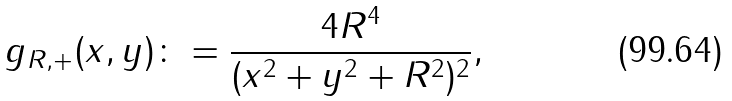<formula> <loc_0><loc_0><loc_500><loc_500>g _ { R , + } ( x , y ) \colon = \frac { 4 R ^ { 4 } } { ( x ^ { 2 } + y ^ { 2 } + R ^ { 2 } ) ^ { 2 } } ,</formula> 